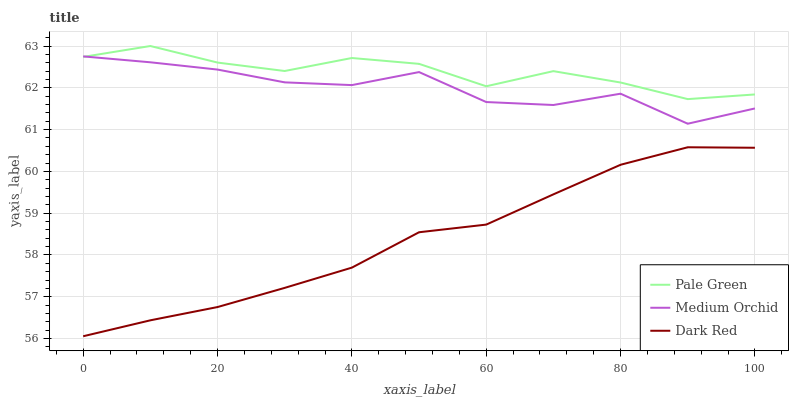Does Dark Red have the minimum area under the curve?
Answer yes or no. Yes. Does Pale Green have the maximum area under the curve?
Answer yes or no. Yes. Does Medium Orchid have the minimum area under the curve?
Answer yes or no. No. Does Medium Orchid have the maximum area under the curve?
Answer yes or no. No. Is Dark Red the smoothest?
Answer yes or no. Yes. Is Medium Orchid the roughest?
Answer yes or no. Yes. Is Pale Green the smoothest?
Answer yes or no. No. Is Pale Green the roughest?
Answer yes or no. No. Does Dark Red have the lowest value?
Answer yes or no. Yes. Does Medium Orchid have the lowest value?
Answer yes or no. No. Does Pale Green have the highest value?
Answer yes or no. Yes. Does Medium Orchid have the highest value?
Answer yes or no. No. Is Dark Red less than Pale Green?
Answer yes or no. Yes. Is Medium Orchid greater than Dark Red?
Answer yes or no. Yes. Does Pale Green intersect Medium Orchid?
Answer yes or no. Yes. Is Pale Green less than Medium Orchid?
Answer yes or no. No. Is Pale Green greater than Medium Orchid?
Answer yes or no. No. Does Dark Red intersect Pale Green?
Answer yes or no. No. 